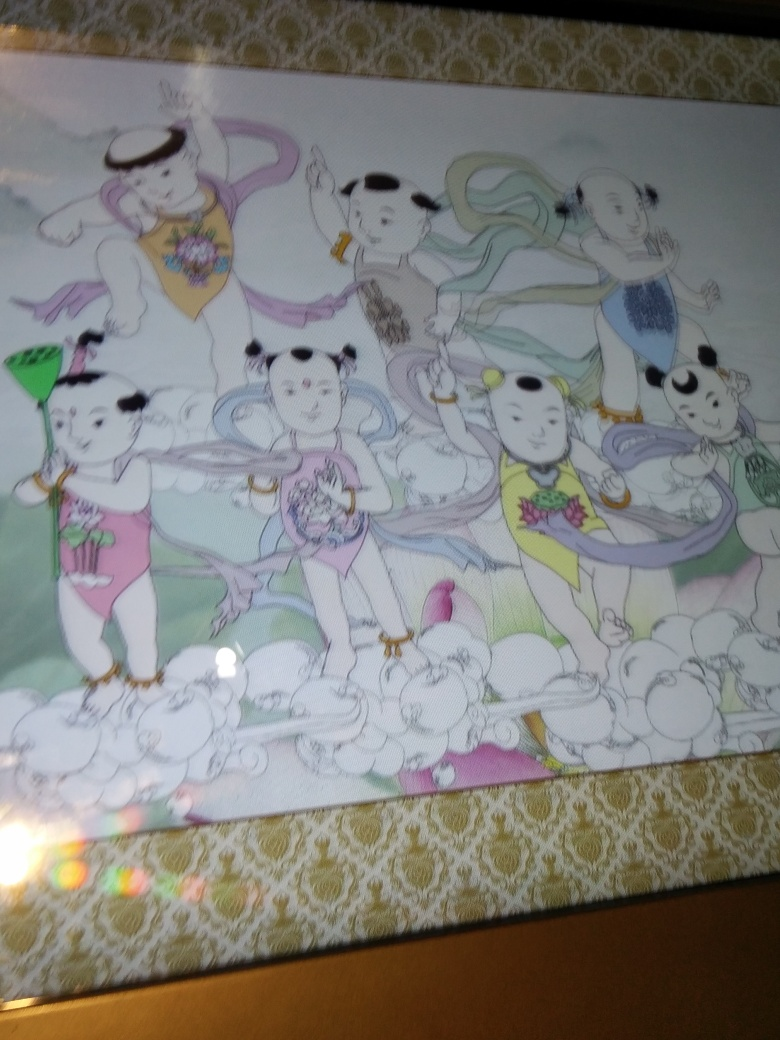Can you describe the theme of this illustration? The illustration seems to capture a whimsical, fantasy theme with characters that resemble humanized pandas engaged in various playful activities. The characters are adorned in traditional-looking attire, which may suggest cultural influences. Each character holds different objects, possibly implying a story or symbolism behind their actions. 